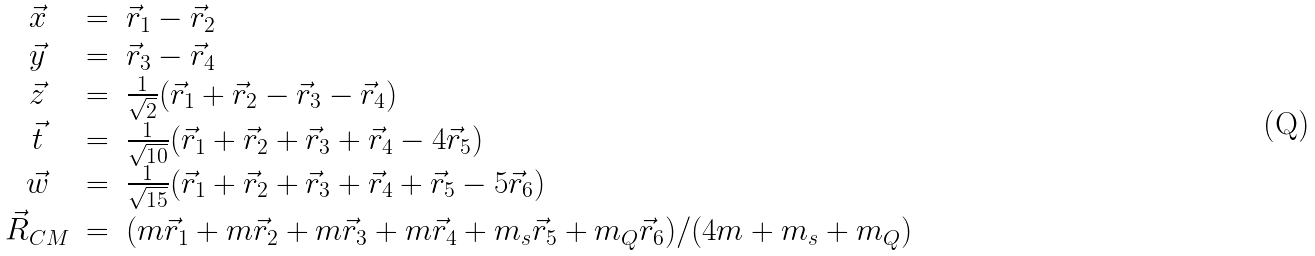Convert formula to latex. <formula><loc_0><loc_0><loc_500><loc_500>\begin{array} { c c l } \vec { x } & = & \vec { r } _ { 1 } - \vec { r } _ { 2 } \\ \vec { y } & = & \vec { r } _ { 3 } - \vec { r } _ { 4 } \\ \vec { z } & = & \frac { 1 } { \sqrt { 2 } } ( \vec { r } _ { 1 } + \vec { r } _ { 2 } - \vec { r } _ { 3 } - \vec { r } _ { 4 } ) \\ \vec { t } & = & \frac { 1 } { \sqrt { 1 0 } } ( \vec { r } _ { 1 } + \vec { r } _ { 2 } + \vec { r } _ { 3 } + \vec { r } _ { 4 } - 4 \vec { r } _ { 5 } ) \\ \vec { w } & = & \frac { 1 } { \sqrt { 1 5 } } ( \vec { r } _ { 1 } + \vec { r } _ { 2 } + \vec { r } _ { 3 } + \vec { r } _ { 4 } + \vec { r } _ { 5 } - 5 \vec { r } _ { 6 } ) \\ \vec { R } _ { C M } & = & ( m \vec { r } _ { 1 } + m \vec { r } _ { 2 } + m \vec { r } _ { 3 } + m \vec { r } _ { 4 } + m _ { s } \vec { r } _ { 5 } + m _ { Q } \vec { r } _ { 6 } ) / ( 4 m + m _ { s } + m _ { Q } ) \end{array}</formula> 